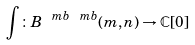Convert formula to latex. <formula><loc_0><loc_0><loc_500><loc_500>\int \colon B ^ { \ m b \ m b } ( m , n ) \to \mathbb { C } [ 0 ]</formula> 